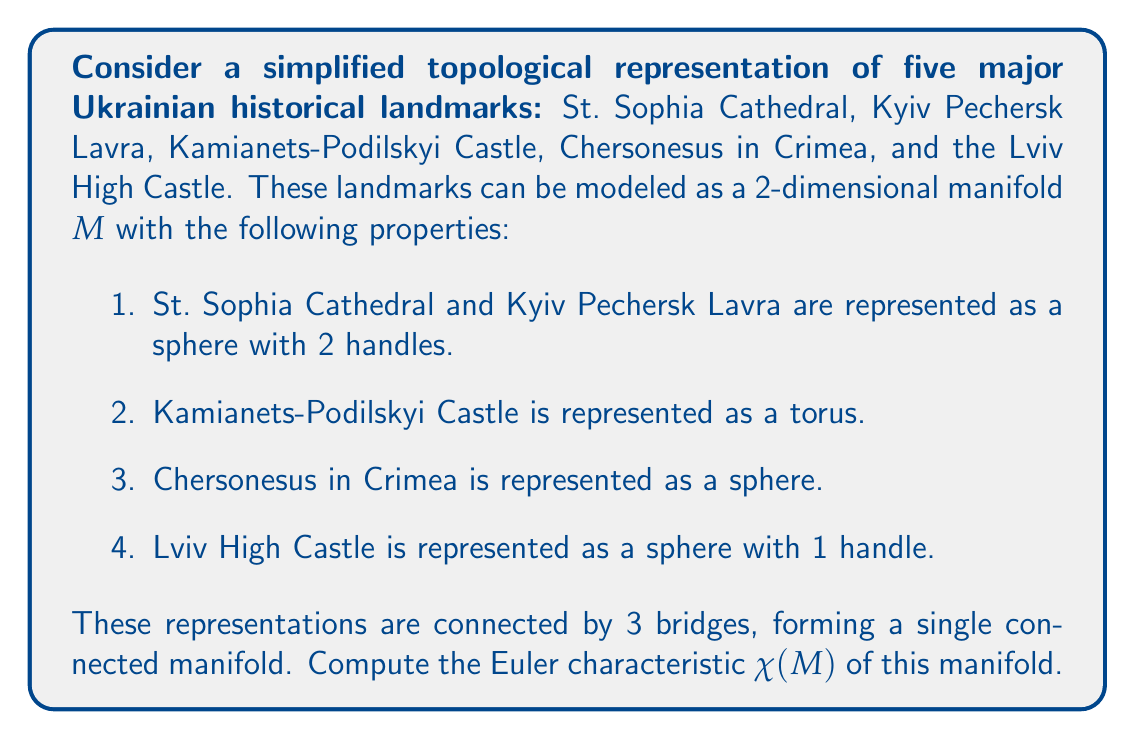Teach me how to tackle this problem. To solve this problem, we'll use the following steps:

1. Recall the formula for the Euler characteristic of a connected sum of manifolds:
   $$\chi(M_1 \# M_2) = \chi(M_1) + \chi(M_2) - 2$$

2. Calculate the Euler characteristic for each component:

   a) St. Sophia Cathedral and Kyiv Pechersk Lavra (sphere with 2 handles):
      $$\chi = 2 - 2g = 2 - 2(2) = -2$$
   
   b) Kamianets-Podilskyi Castle (torus):
      $$\chi = 2 - 2g = 2 - 2(1) = 0$$
   
   c) Chersonesus in Crimea (sphere):
      $$\chi = 2$$
   
   d) Lviv High Castle (sphere with 1 handle):
      $$\chi = 2 - 2g = 2 - 2(1) = 0$$

3. Now, we need to connect these components using the connected sum operation. We have 4 components and 3 bridges, so we'll perform the connected sum operation 3 times:

   $$\begin{align*}
   \chi(M) &= \chi(M_1 \# M_2 \# M_3 \# M_4) \\
   &= (\chi(M_1) + \chi(M_2) - 2) + \chi(M_3) - 2 + \chi(M_4) - 2 \\
   &= \chi(M_1) + \chi(M_2) + \chi(M_3) + \chi(M_4) - 6
   \end{align*}$$

4. Substituting the values:

   $$\begin{align*}
   \chi(M) &= -2 + 0 + 2 + 0 - 6 \\
   &= -6
   \end{align*}$$

Therefore, the Euler characteristic of the manifold representing the topology of these Ukrainian historical landmarks is -6.
Answer: $\chi(M) = -6$ 